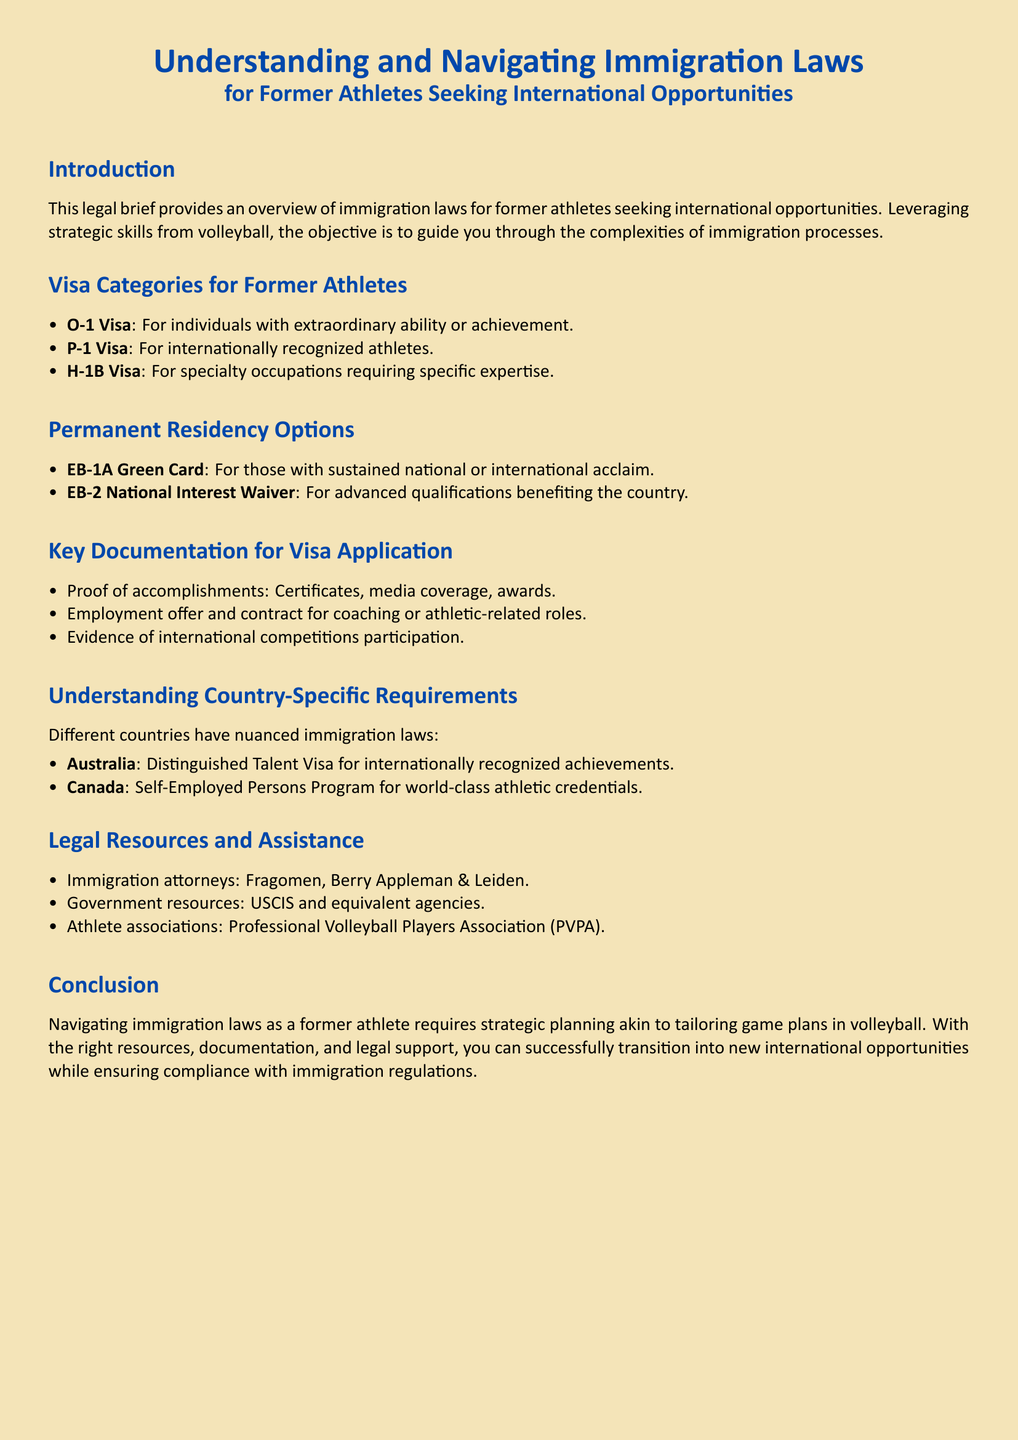What is the purpose of this legal brief? The legal brief provides an overview of immigration laws for former athletes seeking international opportunities.
Answer: Overview of immigration laws What type of visa is for individuals with extraordinary ability? The document mentions the O-1 visa as the type for individuals with extraordinary ability or achievement.
Answer: O-1 Visa Which green card is available for those with national acclaim? The document states that the EB-1A green card is available for those with sustained national or international acclaim.
Answer: EB-1A Green Card What is one key documentation required for the visa application? The document lists proof of accomplishments as one key documentation required for visa applications.
Answer: Proof of accomplishments What is the alternative visa for self-employed athletes in Canada? The document mentions the Self-Employed Persons Program as the alternative visa for self-employed athletes in Canada.
Answer: Self-Employed Persons Program Which country's visa is called the Distinguished Talent Visa? The document identifies Australia as the country that offers the Distinguished Talent Visa for internationally recognized achievements.
Answer: Australia What is one legal resource mentioned for immigration assistance? The document lists immigration attorneys, specifically naming Fragomen as a legal resource for immigration assistance.
Answer: Fragomen How does the document suggest navigating immigration laws? The document suggests that navigating immigration laws requires strategic planning akin to tailoring game plans in volleyball.
Answer: Strategic planning What organization is specifically mentioned for athlete associations? The Professional Volleyball Players Association is mentioned as an athlete association in the document.
Answer: Professional Volleyball Players Association What type of visa is intended for internationally recognized athletes? The P-1 visa is the type intended for internationally recognized athletes according to the document.
Answer: P-1 Visa 